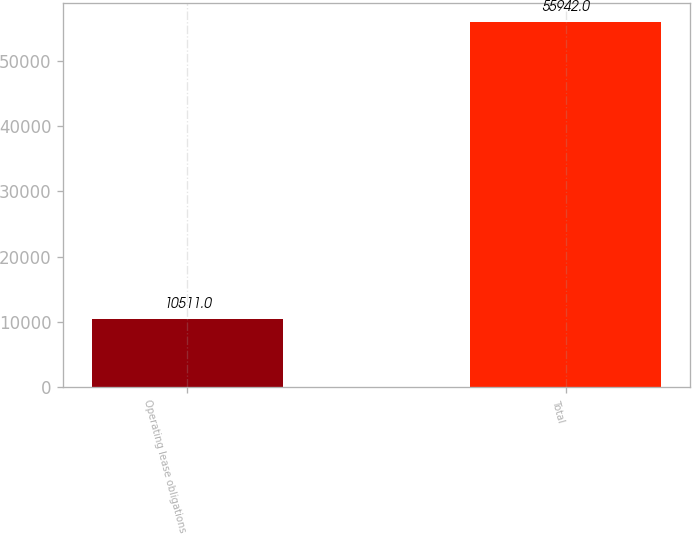<chart> <loc_0><loc_0><loc_500><loc_500><bar_chart><fcel>Operating lease obligations<fcel>Total<nl><fcel>10511<fcel>55942<nl></chart> 